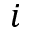<formula> <loc_0><loc_0><loc_500><loc_500>i</formula> 